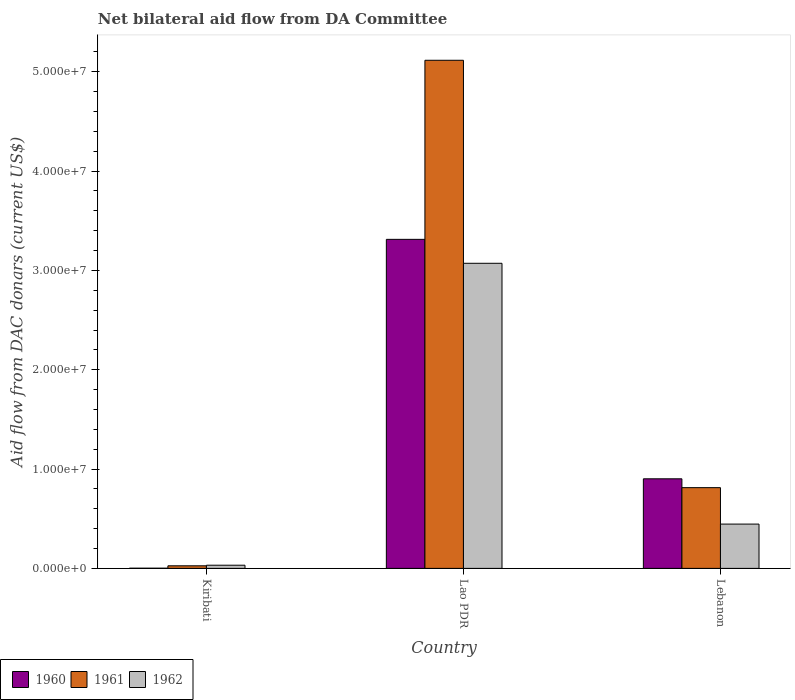How many groups of bars are there?
Your answer should be compact. 3. Are the number of bars on each tick of the X-axis equal?
Keep it short and to the point. Yes. How many bars are there on the 2nd tick from the left?
Ensure brevity in your answer.  3. What is the label of the 2nd group of bars from the left?
Make the answer very short. Lao PDR. What is the aid flow in in 1961 in Lao PDR?
Ensure brevity in your answer.  5.12e+07. Across all countries, what is the maximum aid flow in in 1961?
Ensure brevity in your answer.  5.12e+07. In which country was the aid flow in in 1962 maximum?
Ensure brevity in your answer.  Lao PDR. In which country was the aid flow in in 1962 minimum?
Your response must be concise. Kiribati. What is the total aid flow in in 1960 in the graph?
Your response must be concise. 4.22e+07. What is the difference between the aid flow in in 1960 in Kiribati and that in Lebanon?
Provide a succinct answer. -9.00e+06. What is the difference between the aid flow in in 1961 in Lao PDR and the aid flow in in 1960 in Kiribati?
Your answer should be compact. 5.11e+07. What is the average aid flow in in 1962 per country?
Your answer should be very brief. 1.18e+07. What is the difference between the aid flow in of/in 1961 and aid flow in of/in 1962 in Lebanon?
Make the answer very short. 3.67e+06. In how many countries, is the aid flow in in 1961 greater than 4000000 US$?
Keep it short and to the point. 2. What is the ratio of the aid flow in in 1960 in Kiribati to that in Lebanon?
Your answer should be compact. 0. Is the difference between the aid flow in in 1961 in Kiribati and Lebanon greater than the difference between the aid flow in in 1962 in Kiribati and Lebanon?
Ensure brevity in your answer.  No. What is the difference between the highest and the second highest aid flow in in 1962?
Your response must be concise. 3.04e+07. What is the difference between the highest and the lowest aid flow in in 1960?
Provide a short and direct response. 3.31e+07. In how many countries, is the aid flow in in 1961 greater than the average aid flow in in 1961 taken over all countries?
Keep it short and to the point. 1. Is the sum of the aid flow in in 1960 in Lao PDR and Lebanon greater than the maximum aid flow in in 1961 across all countries?
Make the answer very short. No. What does the 3rd bar from the right in Lebanon represents?
Your answer should be very brief. 1960. How many bars are there?
Provide a short and direct response. 9. What is the difference between two consecutive major ticks on the Y-axis?
Provide a succinct answer. 1.00e+07. Are the values on the major ticks of Y-axis written in scientific E-notation?
Ensure brevity in your answer.  Yes. Where does the legend appear in the graph?
Give a very brief answer. Bottom left. How many legend labels are there?
Ensure brevity in your answer.  3. What is the title of the graph?
Ensure brevity in your answer.  Net bilateral aid flow from DA Committee. What is the label or title of the Y-axis?
Ensure brevity in your answer.  Aid flow from DAC donars (current US$). What is the Aid flow from DAC donars (current US$) of 1962 in Kiribati?
Ensure brevity in your answer.  3.20e+05. What is the Aid flow from DAC donars (current US$) of 1960 in Lao PDR?
Keep it short and to the point. 3.31e+07. What is the Aid flow from DAC donars (current US$) in 1961 in Lao PDR?
Ensure brevity in your answer.  5.12e+07. What is the Aid flow from DAC donars (current US$) in 1962 in Lao PDR?
Provide a short and direct response. 3.07e+07. What is the Aid flow from DAC donars (current US$) of 1960 in Lebanon?
Offer a very short reply. 9.02e+06. What is the Aid flow from DAC donars (current US$) of 1961 in Lebanon?
Offer a very short reply. 8.13e+06. What is the Aid flow from DAC donars (current US$) of 1962 in Lebanon?
Make the answer very short. 4.46e+06. Across all countries, what is the maximum Aid flow from DAC donars (current US$) in 1960?
Provide a short and direct response. 3.31e+07. Across all countries, what is the maximum Aid flow from DAC donars (current US$) of 1961?
Offer a terse response. 5.12e+07. Across all countries, what is the maximum Aid flow from DAC donars (current US$) of 1962?
Make the answer very short. 3.07e+07. Across all countries, what is the minimum Aid flow from DAC donars (current US$) of 1961?
Keep it short and to the point. 2.60e+05. Across all countries, what is the minimum Aid flow from DAC donars (current US$) in 1962?
Provide a short and direct response. 3.20e+05. What is the total Aid flow from DAC donars (current US$) of 1960 in the graph?
Make the answer very short. 4.22e+07. What is the total Aid flow from DAC donars (current US$) in 1961 in the graph?
Your response must be concise. 5.96e+07. What is the total Aid flow from DAC donars (current US$) of 1962 in the graph?
Your answer should be compact. 3.55e+07. What is the difference between the Aid flow from DAC donars (current US$) in 1960 in Kiribati and that in Lao PDR?
Make the answer very short. -3.31e+07. What is the difference between the Aid flow from DAC donars (current US$) in 1961 in Kiribati and that in Lao PDR?
Provide a short and direct response. -5.09e+07. What is the difference between the Aid flow from DAC donars (current US$) in 1962 in Kiribati and that in Lao PDR?
Ensure brevity in your answer.  -3.04e+07. What is the difference between the Aid flow from DAC donars (current US$) of 1960 in Kiribati and that in Lebanon?
Offer a very short reply. -9.00e+06. What is the difference between the Aid flow from DAC donars (current US$) in 1961 in Kiribati and that in Lebanon?
Your answer should be compact. -7.87e+06. What is the difference between the Aid flow from DAC donars (current US$) of 1962 in Kiribati and that in Lebanon?
Give a very brief answer. -4.14e+06. What is the difference between the Aid flow from DAC donars (current US$) in 1960 in Lao PDR and that in Lebanon?
Offer a terse response. 2.41e+07. What is the difference between the Aid flow from DAC donars (current US$) in 1961 in Lao PDR and that in Lebanon?
Ensure brevity in your answer.  4.30e+07. What is the difference between the Aid flow from DAC donars (current US$) in 1962 in Lao PDR and that in Lebanon?
Your answer should be very brief. 2.63e+07. What is the difference between the Aid flow from DAC donars (current US$) of 1960 in Kiribati and the Aid flow from DAC donars (current US$) of 1961 in Lao PDR?
Offer a terse response. -5.11e+07. What is the difference between the Aid flow from DAC donars (current US$) in 1960 in Kiribati and the Aid flow from DAC donars (current US$) in 1962 in Lao PDR?
Offer a terse response. -3.07e+07. What is the difference between the Aid flow from DAC donars (current US$) of 1961 in Kiribati and the Aid flow from DAC donars (current US$) of 1962 in Lao PDR?
Give a very brief answer. -3.05e+07. What is the difference between the Aid flow from DAC donars (current US$) of 1960 in Kiribati and the Aid flow from DAC donars (current US$) of 1961 in Lebanon?
Provide a short and direct response. -8.11e+06. What is the difference between the Aid flow from DAC donars (current US$) in 1960 in Kiribati and the Aid flow from DAC donars (current US$) in 1962 in Lebanon?
Provide a short and direct response. -4.44e+06. What is the difference between the Aid flow from DAC donars (current US$) of 1961 in Kiribati and the Aid flow from DAC donars (current US$) of 1962 in Lebanon?
Ensure brevity in your answer.  -4.20e+06. What is the difference between the Aid flow from DAC donars (current US$) of 1960 in Lao PDR and the Aid flow from DAC donars (current US$) of 1961 in Lebanon?
Ensure brevity in your answer.  2.50e+07. What is the difference between the Aid flow from DAC donars (current US$) in 1960 in Lao PDR and the Aid flow from DAC donars (current US$) in 1962 in Lebanon?
Give a very brief answer. 2.87e+07. What is the difference between the Aid flow from DAC donars (current US$) in 1961 in Lao PDR and the Aid flow from DAC donars (current US$) in 1962 in Lebanon?
Provide a succinct answer. 4.67e+07. What is the average Aid flow from DAC donars (current US$) in 1960 per country?
Your answer should be compact. 1.41e+07. What is the average Aid flow from DAC donars (current US$) of 1961 per country?
Make the answer very short. 1.98e+07. What is the average Aid flow from DAC donars (current US$) in 1962 per country?
Offer a very short reply. 1.18e+07. What is the difference between the Aid flow from DAC donars (current US$) of 1960 and Aid flow from DAC donars (current US$) of 1962 in Kiribati?
Give a very brief answer. -3.00e+05. What is the difference between the Aid flow from DAC donars (current US$) in 1960 and Aid flow from DAC donars (current US$) in 1961 in Lao PDR?
Offer a very short reply. -1.80e+07. What is the difference between the Aid flow from DAC donars (current US$) of 1960 and Aid flow from DAC donars (current US$) of 1962 in Lao PDR?
Provide a short and direct response. 2.41e+06. What is the difference between the Aid flow from DAC donars (current US$) of 1961 and Aid flow from DAC donars (current US$) of 1962 in Lao PDR?
Ensure brevity in your answer.  2.04e+07. What is the difference between the Aid flow from DAC donars (current US$) of 1960 and Aid flow from DAC donars (current US$) of 1961 in Lebanon?
Your response must be concise. 8.90e+05. What is the difference between the Aid flow from DAC donars (current US$) of 1960 and Aid flow from DAC donars (current US$) of 1962 in Lebanon?
Provide a succinct answer. 4.56e+06. What is the difference between the Aid flow from DAC donars (current US$) of 1961 and Aid flow from DAC donars (current US$) of 1962 in Lebanon?
Offer a very short reply. 3.67e+06. What is the ratio of the Aid flow from DAC donars (current US$) in 1960 in Kiribati to that in Lao PDR?
Keep it short and to the point. 0. What is the ratio of the Aid flow from DAC donars (current US$) in 1961 in Kiribati to that in Lao PDR?
Your answer should be compact. 0.01. What is the ratio of the Aid flow from DAC donars (current US$) in 1962 in Kiribati to that in Lao PDR?
Make the answer very short. 0.01. What is the ratio of the Aid flow from DAC donars (current US$) in 1960 in Kiribati to that in Lebanon?
Your answer should be compact. 0. What is the ratio of the Aid flow from DAC donars (current US$) in 1961 in Kiribati to that in Lebanon?
Your answer should be compact. 0.03. What is the ratio of the Aid flow from DAC donars (current US$) in 1962 in Kiribati to that in Lebanon?
Keep it short and to the point. 0.07. What is the ratio of the Aid flow from DAC donars (current US$) in 1960 in Lao PDR to that in Lebanon?
Your answer should be compact. 3.67. What is the ratio of the Aid flow from DAC donars (current US$) in 1961 in Lao PDR to that in Lebanon?
Your answer should be compact. 6.29. What is the ratio of the Aid flow from DAC donars (current US$) of 1962 in Lao PDR to that in Lebanon?
Provide a succinct answer. 6.89. What is the difference between the highest and the second highest Aid flow from DAC donars (current US$) of 1960?
Make the answer very short. 2.41e+07. What is the difference between the highest and the second highest Aid flow from DAC donars (current US$) in 1961?
Your answer should be compact. 4.30e+07. What is the difference between the highest and the second highest Aid flow from DAC donars (current US$) in 1962?
Provide a succinct answer. 2.63e+07. What is the difference between the highest and the lowest Aid flow from DAC donars (current US$) of 1960?
Provide a succinct answer. 3.31e+07. What is the difference between the highest and the lowest Aid flow from DAC donars (current US$) in 1961?
Offer a very short reply. 5.09e+07. What is the difference between the highest and the lowest Aid flow from DAC donars (current US$) of 1962?
Offer a terse response. 3.04e+07. 